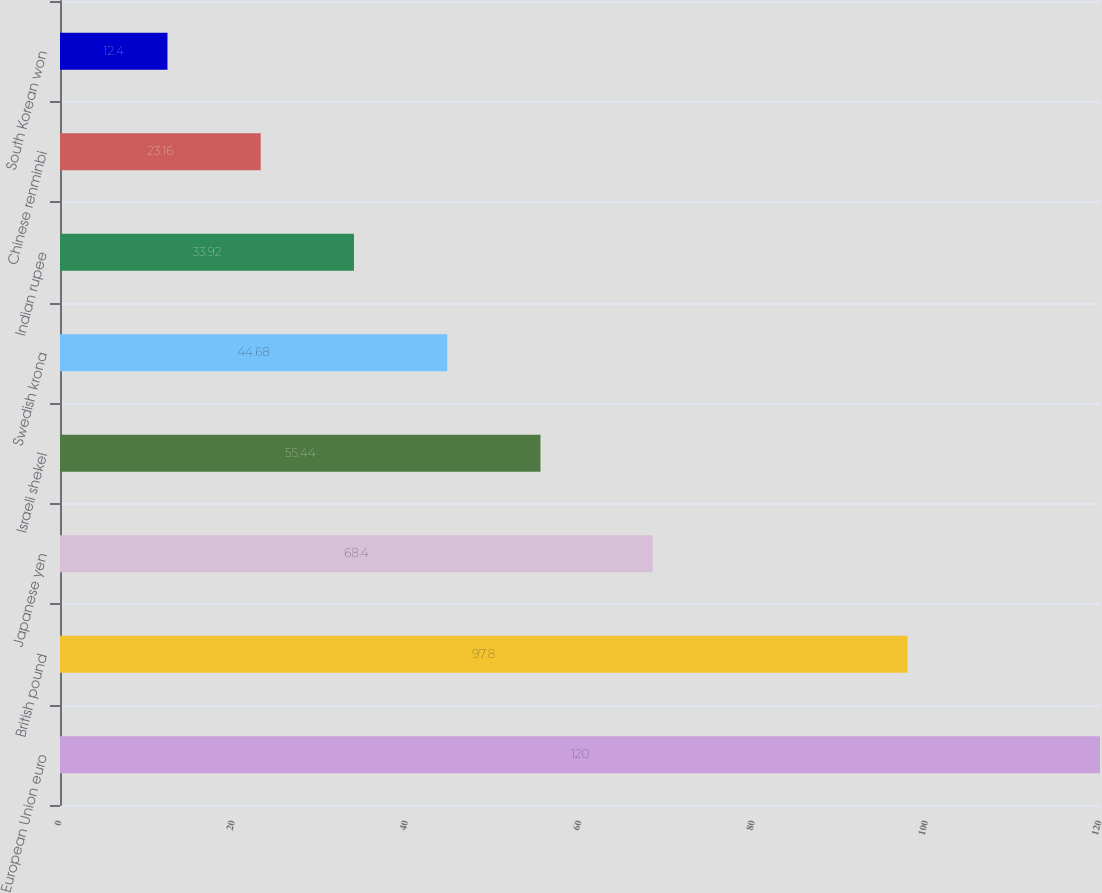Convert chart to OTSL. <chart><loc_0><loc_0><loc_500><loc_500><bar_chart><fcel>European Union euro<fcel>British pound<fcel>Japanese yen<fcel>Israeli shekel<fcel>Swedish krona<fcel>Indian rupee<fcel>Chinese renminbi<fcel>South Korean won<nl><fcel>120<fcel>97.8<fcel>68.4<fcel>55.44<fcel>44.68<fcel>33.92<fcel>23.16<fcel>12.4<nl></chart> 